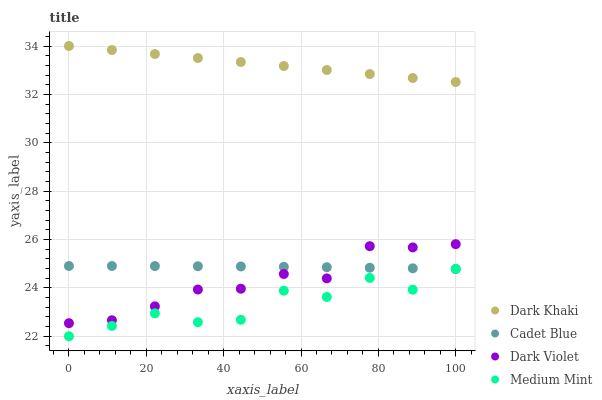Does Medium Mint have the minimum area under the curve?
Answer yes or no. Yes. Does Dark Khaki have the maximum area under the curve?
Answer yes or no. Yes. Does Cadet Blue have the minimum area under the curve?
Answer yes or no. No. Does Cadet Blue have the maximum area under the curve?
Answer yes or no. No. Is Dark Khaki the smoothest?
Answer yes or no. Yes. Is Medium Mint the roughest?
Answer yes or no. Yes. Is Cadet Blue the smoothest?
Answer yes or no. No. Is Cadet Blue the roughest?
Answer yes or no. No. Does Medium Mint have the lowest value?
Answer yes or no. Yes. Does Cadet Blue have the lowest value?
Answer yes or no. No. Does Dark Khaki have the highest value?
Answer yes or no. Yes. Does Cadet Blue have the highest value?
Answer yes or no. No. Is Medium Mint less than Dark Violet?
Answer yes or no. Yes. Is Dark Violet greater than Medium Mint?
Answer yes or no. Yes. Does Dark Violet intersect Cadet Blue?
Answer yes or no. Yes. Is Dark Violet less than Cadet Blue?
Answer yes or no. No. Is Dark Violet greater than Cadet Blue?
Answer yes or no. No. Does Medium Mint intersect Dark Violet?
Answer yes or no. No. 